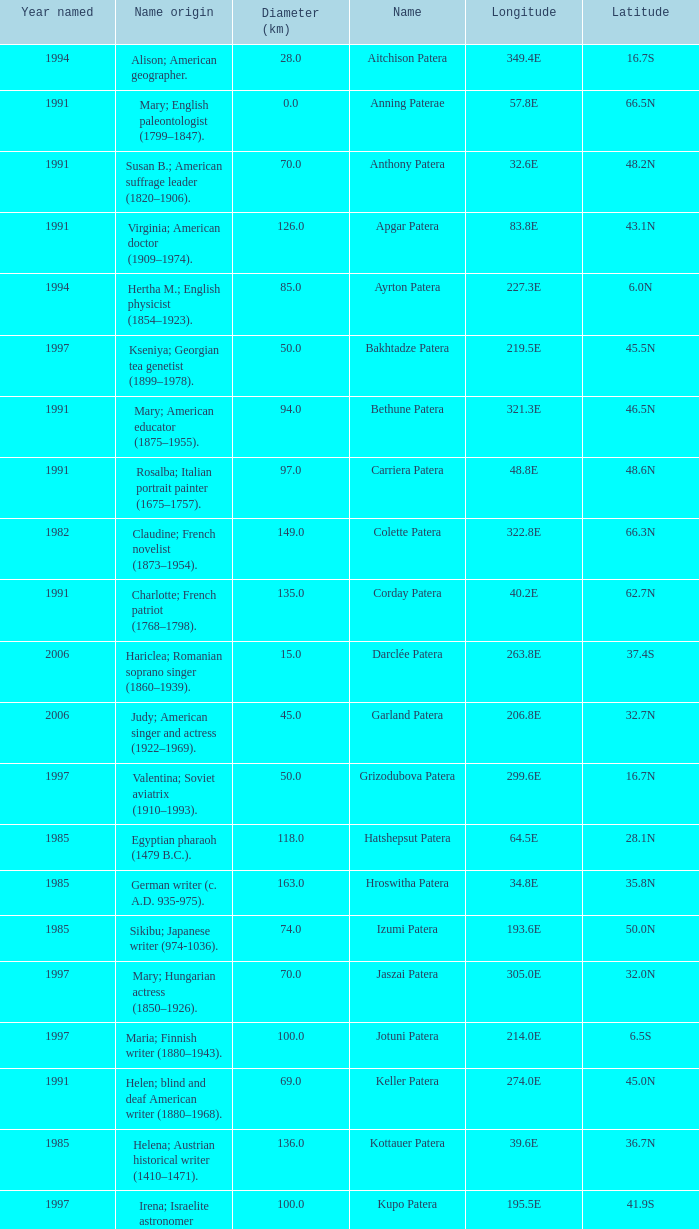What is the longitude of the feature named Razia Patera?  197.8E. 